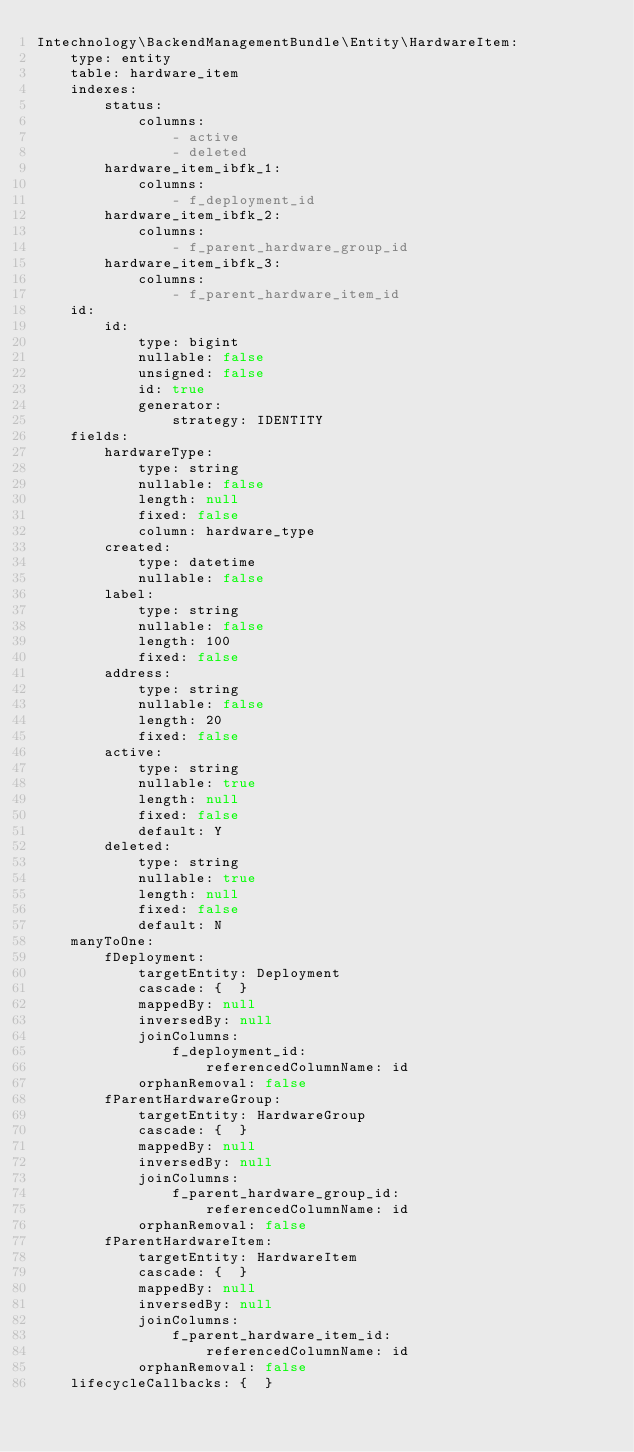<code> <loc_0><loc_0><loc_500><loc_500><_YAML_>Intechnology\BackendManagementBundle\Entity\HardwareItem:
    type: entity
    table: hardware_item
    indexes:
        status:
            columns:
                - active
                - deleted
        hardware_item_ibfk_1:
            columns:
                - f_deployment_id
        hardware_item_ibfk_2:
            columns:
                - f_parent_hardware_group_id
        hardware_item_ibfk_3:
            columns:
                - f_parent_hardware_item_id
    id:
        id:
            type: bigint
            nullable: false
            unsigned: false
            id: true
            generator:
                strategy: IDENTITY
    fields:
        hardwareType:
            type: string
            nullable: false
            length: null
            fixed: false
            column: hardware_type
        created:
            type: datetime
            nullable: false
        label:
            type: string
            nullable: false
            length: 100
            fixed: false
        address:
            type: string
            nullable: false
            length: 20
            fixed: false
        active:
            type: string
            nullable: true
            length: null
            fixed: false
            default: Y
        deleted:
            type: string
            nullable: true
            length: null
            fixed: false
            default: N
    manyToOne:
        fDeployment:
            targetEntity: Deployment
            cascade: {  }
            mappedBy: null
            inversedBy: null
            joinColumns:
                f_deployment_id:
                    referencedColumnName: id
            orphanRemoval: false
        fParentHardwareGroup:
            targetEntity: HardwareGroup
            cascade: {  }
            mappedBy: null
            inversedBy: null
            joinColumns:
                f_parent_hardware_group_id:
                    referencedColumnName: id
            orphanRemoval: false
        fParentHardwareItem:
            targetEntity: HardwareItem
            cascade: {  }
            mappedBy: null
            inversedBy: null
            joinColumns:
                f_parent_hardware_item_id:
                    referencedColumnName: id
            orphanRemoval: false
    lifecycleCallbacks: {  }
</code> 